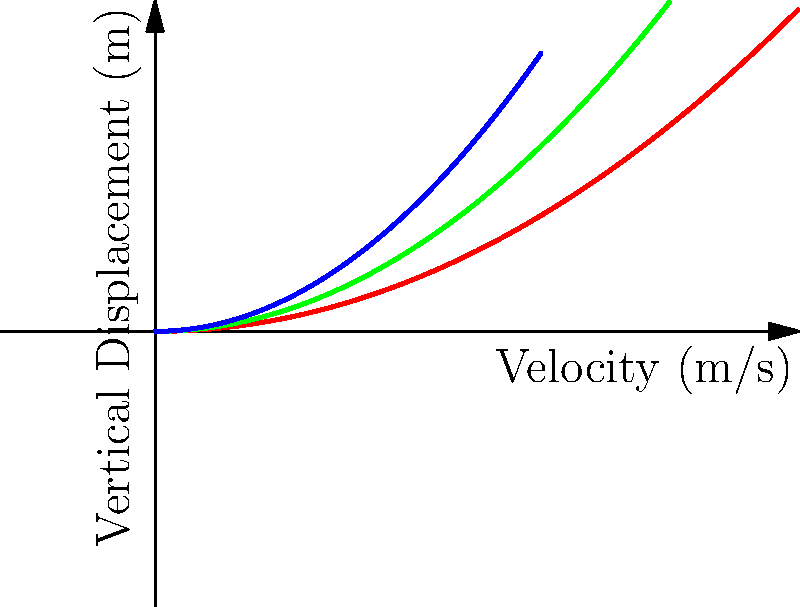Based on the velocity vector diagrams for different bowling deliveries, which type of delivery is likely to have the highest initial velocity but the least vertical displacement at the same horizontal distance? To answer this question, we need to analyze the velocity vector diagrams for the three types of bowling deliveries:

1. Fast (red curve): This curve has the longest horizontal reach, indicating the highest initial velocity. It also has the flattest trajectory, showing the least vertical displacement for a given horizontal distance.

2. Medium (green curve): This curve shows a moderate initial velocity and vertical displacement, falling between the fast and spin deliveries.

3. Spin (blue curve): This curve has the shortest horizontal reach, suggesting the lowest initial velocity. It also shows the highest vertical displacement for a given horizontal distance.

The key points to consider are:

a) Initial velocity is indicated by the horizontal reach of the curve. The longer the curve extends horizontally, the higher the initial velocity.

b) Vertical displacement is shown by how quickly the curve rises. A flatter curve indicates less vertical displacement for the same horizontal distance.

Comparing these factors, we can see that the fast delivery (red curve) extends the furthest horizontally, indicating the highest initial velocity. At the same time, it has the flattest trajectory, showing the least vertical displacement for any given horizontal distance.

Therefore, the fast bowling delivery best fits the description in the question.
Answer: Fast bowling delivery 